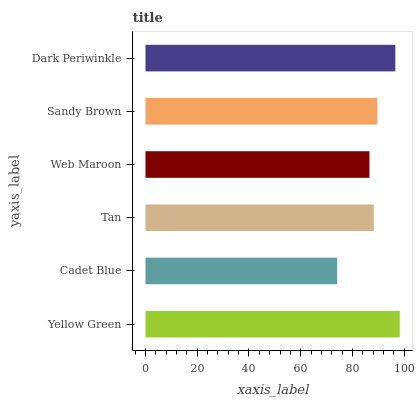Is Cadet Blue the minimum?
Answer yes or no. Yes. Is Yellow Green the maximum?
Answer yes or no. Yes. Is Tan the minimum?
Answer yes or no. No. Is Tan the maximum?
Answer yes or no. No. Is Tan greater than Cadet Blue?
Answer yes or no. Yes. Is Cadet Blue less than Tan?
Answer yes or no. Yes. Is Cadet Blue greater than Tan?
Answer yes or no. No. Is Tan less than Cadet Blue?
Answer yes or no. No. Is Sandy Brown the high median?
Answer yes or no. Yes. Is Tan the low median?
Answer yes or no. Yes. Is Tan the high median?
Answer yes or no. No. Is Web Maroon the low median?
Answer yes or no. No. 